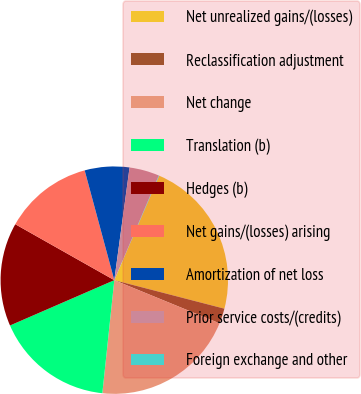Convert chart to OTSL. <chart><loc_0><loc_0><loc_500><loc_500><pie_chart><fcel>Net unrealized gains/(losses)<fcel>Reclassification adjustment<fcel>Net change<fcel>Translation (b)<fcel>Hedges (b)<fcel>Net gains/(losses) arising<fcel>Amortization of net loss<fcel>Prior service costs/(credits)<fcel>Foreign exchange and other<nl><fcel>22.57%<fcel>2.16%<fcel>20.48%<fcel>16.8%<fcel>14.71%<fcel>12.62%<fcel>6.34%<fcel>4.25%<fcel>0.07%<nl></chart> 